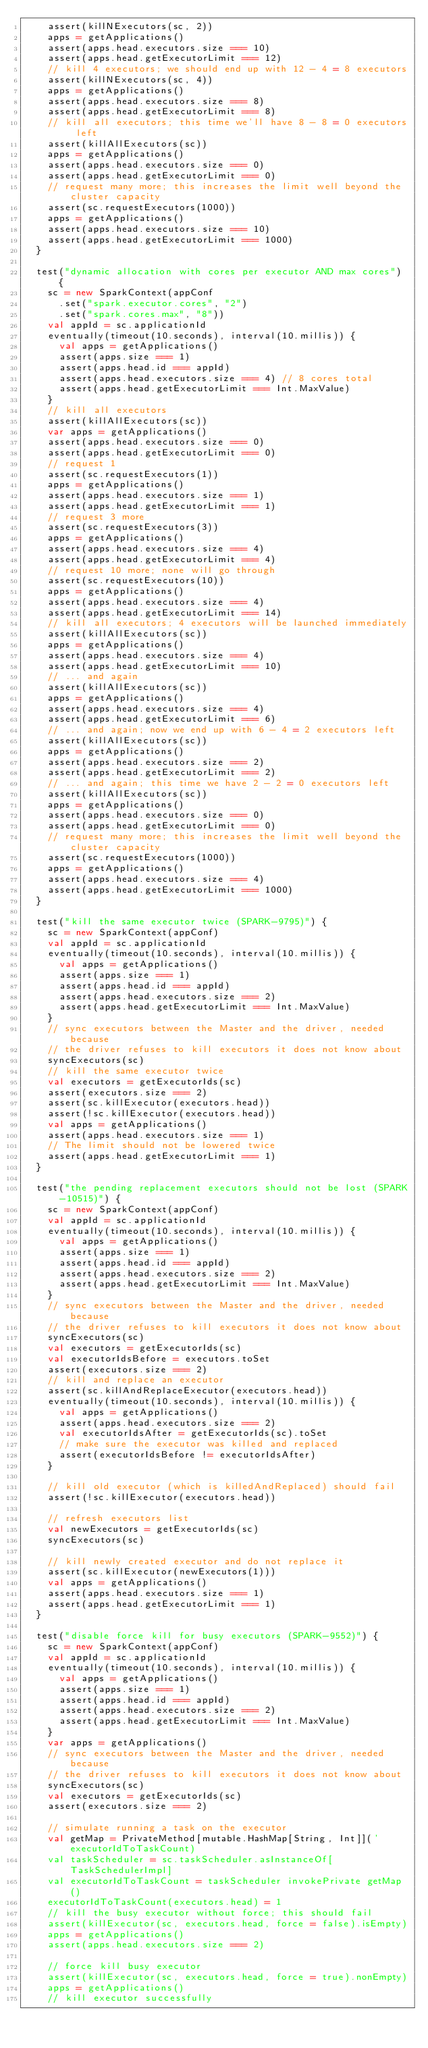<code> <loc_0><loc_0><loc_500><loc_500><_Scala_>    assert(killNExecutors(sc, 2))
    apps = getApplications()
    assert(apps.head.executors.size === 10)
    assert(apps.head.getExecutorLimit === 12)
    // kill 4 executors; we should end up with 12 - 4 = 8 executors
    assert(killNExecutors(sc, 4))
    apps = getApplications()
    assert(apps.head.executors.size === 8)
    assert(apps.head.getExecutorLimit === 8)
    // kill all executors; this time we'll have 8 - 8 = 0 executors left
    assert(killAllExecutors(sc))
    apps = getApplications()
    assert(apps.head.executors.size === 0)
    assert(apps.head.getExecutorLimit === 0)
    // request many more; this increases the limit well beyond the cluster capacity
    assert(sc.requestExecutors(1000))
    apps = getApplications()
    assert(apps.head.executors.size === 10)
    assert(apps.head.getExecutorLimit === 1000)
  }

  test("dynamic allocation with cores per executor AND max cores") {
    sc = new SparkContext(appConf
      .set("spark.executor.cores", "2")
      .set("spark.cores.max", "8"))
    val appId = sc.applicationId
    eventually(timeout(10.seconds), interval(10.millis)) {
      val apps = getApplications()
      assert(apps.size === 1)
      assert(apps.head.id === appId)
      assert(apps.head.executors.size === 4) // 8 cores total
      assert(apps.head.getExecutorLimit === Int.MaxValue)
    }
    // kill all executors
    assert(killAllExecutors(sc))
    var apps = getApplications()
    assert(apps.head.executors.size === 0)
    assert(apps.head.getExecutorLimit === 0)
    // request 1
    assert(sc.requestExecutors(1))
    apps = getApplications()
    assert(apps.head.executors.size === 1)
    assert(apps.head.getExecutorLimit === 1)
    // request 3 more
    assert(sc.requestExecutors(3))
    apps = getApplications()
    assert(apps.head.executors.size === 4)
    assert(apps.head.getExecutorLimit === 4)
    // request 10 more; none will go through
    assert(sc.requestExecutors(10))
    apps = getApplications()
    assert(apps.head.executors.size === 4)
    assert(apps.head.getExecutorLimit === 14)
    // kill all executors; 4 executors will be launched immediately
    assert(killAllExecutors(sc))
    apps = getApplications()
    assert(apps.head.executors.size === 4)
    assert(apps.head.getExecutorLimit === 10)
    // ... and again
    assert(killAllExecutors(sc))
    apps = getApplications()
    assert(apps.head.executors.size === 4)
    assert(apps.head.getExecutorLimit === 6)
    // ... and again; now we end up with 6 - 4 = 2 executors left
    assert(killAllExecutors(sc))
    apps = getApplications()
    assert(apps.head.executors.size === 2)
    assert(apps.head.getExecutorLimit === 2)
    // ... and again; this time we have 2 - 2 = 0 executors left
    assert(killAllExecutors(sc))
    apps = getApplications()
    assert(apps.head.executors.size === 0)
    assert(apps.head.getExecutorLimit === 0)
    // request many more; this increases the limit well beyond the cluster capacity
    assert(sc.requestExecutors(1000))
    apps = getApplications()
    assert(apps.head.executors.size === 4)
    assert(apps.head.getExecutorLimit === 1000)
  }

  test("kill the same executor twice (SPARK-9795)") {
    sc = new SparkContext(appConf)
    val appId = sc.applicationId
    eventually(timeout(10.seconds), interval(10.millis)) {
      val apps = getApplications()
      assert(apps.size === 1)
      assert(apps.head.id === appId)
      assert(apps.head.executors.size === 2)
      assert(apps.head.getExecutorLimit === Int.MaxValue)
    }
    // sync executors between the Master and the driver, needed because
    // the driver refuses to kill executors it does not know about
    syncExecutors(sc)
    // kill the same executor twice
    val executors = getExecutorIds(sc)
    assert(executors.size === 2)
    assert(sc.killExecutor(executors.head))
    assert(!sc.killExecutor(executors.head))
    val apps = getApplications()
    assert(apps.head.executors.size === 1)
    // The limit should not be lowered twice
    assert(apps.head.getExecutorLimit === 1)
  }

  test("the pending replacement executors should not be lost (SPARK-10515)") {
    sc = new SparkContext(appConf)
    val appId = sc.applicationId
    eventually(timeout(10.seconds), interval(10.millis)) {
      val apps = getApplications()
      assert(apps.size === 1)
      assert(apps.head.id === appId)
      assert(apps.head.executors.size === 2)
      assert(apps.head.getExecutorLimit === Int.MaxValue)
    }
    // sync executors between the Master and the driver, needed because
    // the driver refuses to kill executors it does not know about
    syncExecutors(sc)
    val executors = getExecutorIds(sc)
    val executorIdsBefore = executors.toSet
    assert(executors.size === 2)
    // kill and replace an executor
    assert(sc.killAndReplaceExecutor(executors.head))
    eventually(timeout(10.seconds), interval(10.millis)) {
      val apps = getApplications()
      assert(apps.head.executors.size === 2)
      val executorIdsAfter = getExecutorIds(sc).toSet
      // make sure the executor was killed and replaced
      assert(executorIdsBefore != executorIdsAfter)
    }

    // kill old executor (which is killedAndReplaced) should fail
    assert(!sc.killExecutor(executors.head))

    // refresh executors list
    val newExecutors = getExecutorIds(sc)
    syncExecutors(sc)

    // kill newly created executor and do not replace it
    assert(sc.killExecutor(newExecutors(1)))
    val apps = getApplications()
    assert(apps.head.executors.size === 1)
    assert(apps.head.getExecutorLimit === 1)
  }

  test("disable force kill for busy executors (SPARK-9552)") {
    sc = new SparkContext(appConf)
    val appId = sc.applicationId
    eventually(timeout(10.seconds), interval(10.millis)) {
      val apps = getApplications()
      assert(apps.size === 1)
      assert(apps.head.id === appId)
      assert(apps.head.executors.size === 2)
      assert(apps.head.getExecutorLimit === Int.MaxValue)
    }
    var apps = getApplications()
    // sync executors between the Master and the driver, needed because
    // the driver refuses to kill executors it does not know about
    syncExecutors(sc)
    val executors = getExecutorIds(sc)
    assert(executors.size === 2)

    // simulate running a task on the executor
    val getMap = PrivateMethod[mutable.HashMap[String, Int]]('executorIdToTaskCount)
    val taskScheduler = sc.taskScheduler.asInstanceOf[TaskSchedulerImpl]
    val executorIdToTaskCount = taskScheduler invokePrivate getMap()
    executorIdToTaskCount(executors.head) = 1
    // kill the busy executor without force; this should fail
    assert(killExecutor(sc, executors.head, force = false).isEmpty)
    apps = getApplications()
    assert(apps.head.executors.size === 2)

    // force kill busy executor
    assert(killExecutor(sc, executors.head, force = true).nonEmpty)
    apps = getApplications()
    // kill executor successfully</code> 